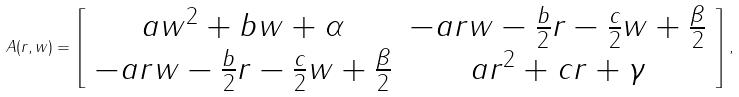<formula> <loc_0><loc_0><loc_500><loc_500>A ( r , w ) = \left [ \begin{array} { c c } a w ^ { 2 } + b w + \alpha & - a r w - \frac { b } { 2 } r - \frac { c } { 2 } w + \frac { \beta } { 2 } \\ - a r w - \frac { b } { 2 } r - \frac { c } { 2 } w + \frac { \beta } { 2 } & a r ^ { 2 } + c r + \gamma \end{array} \right ] ,</formula> 